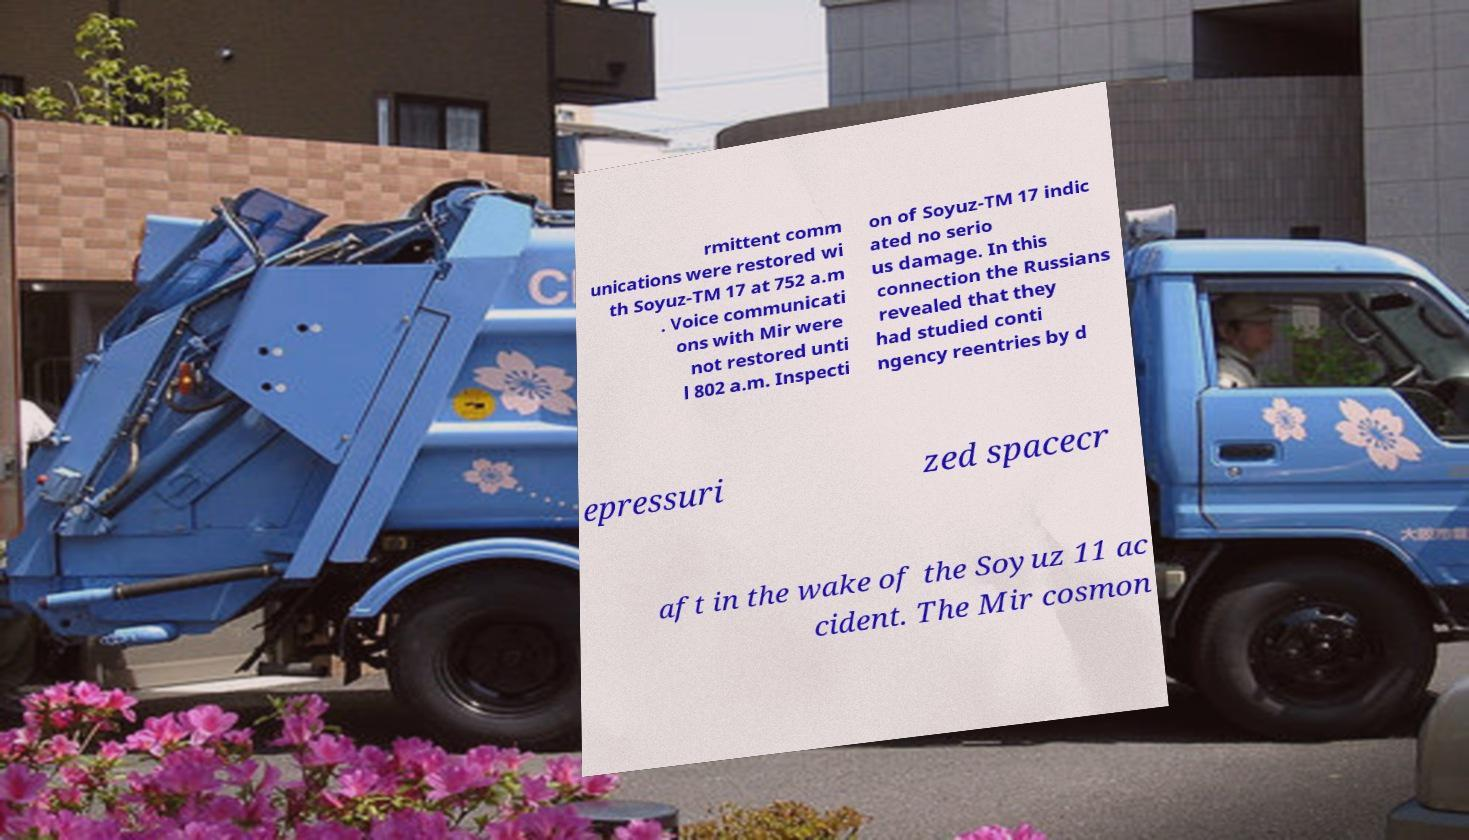Can you accurately transcribe the text from the provided image for me? rmittent comm unications were restored wi th Soyuz-TM 17 at 752 a.m . Voice communicati ons with Mir were not restored unti l 802 a.m. Inspecti on of Soyuz-TM 17 indic ated no serio us damage. In this connection the Russians revealed that they had studied conti ngency reentries by d epressuri zed spacecr aft in the wake of the Soyuz 11 ac cident. The Mir cosmon 